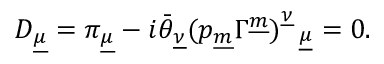<formula> <loc_0><loc_0><loc_500><loc_500>D _ { \underline { \mu } } = \pi _ { \underline { \mu } } - i \bar { \theta } _ { \underline { \nu } } ( p _ { \underline { m } } \Gamma ^ { \underline { m } } ) _ { \underline { \mu } } ^ { \underline { \nu } } = 0 .</formula> 